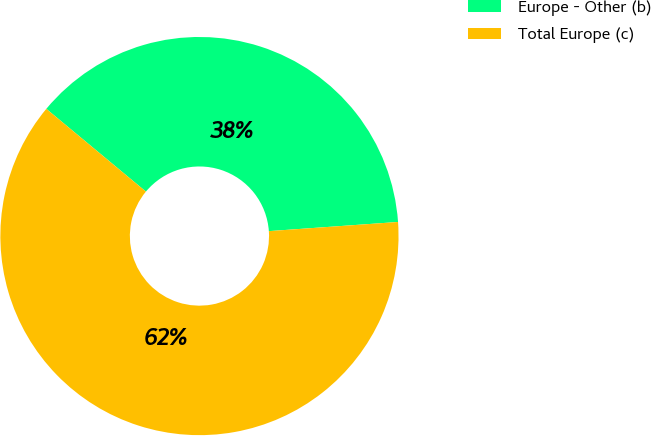Convert chart. <chart><loc_0><loc_0><loc_500><loc_500><pie_chart><fcel>Europe - Other (b)<fcel>Total Europe (c)<nl><fcel>37.84%<fcel>62.16%<nl></chart> 